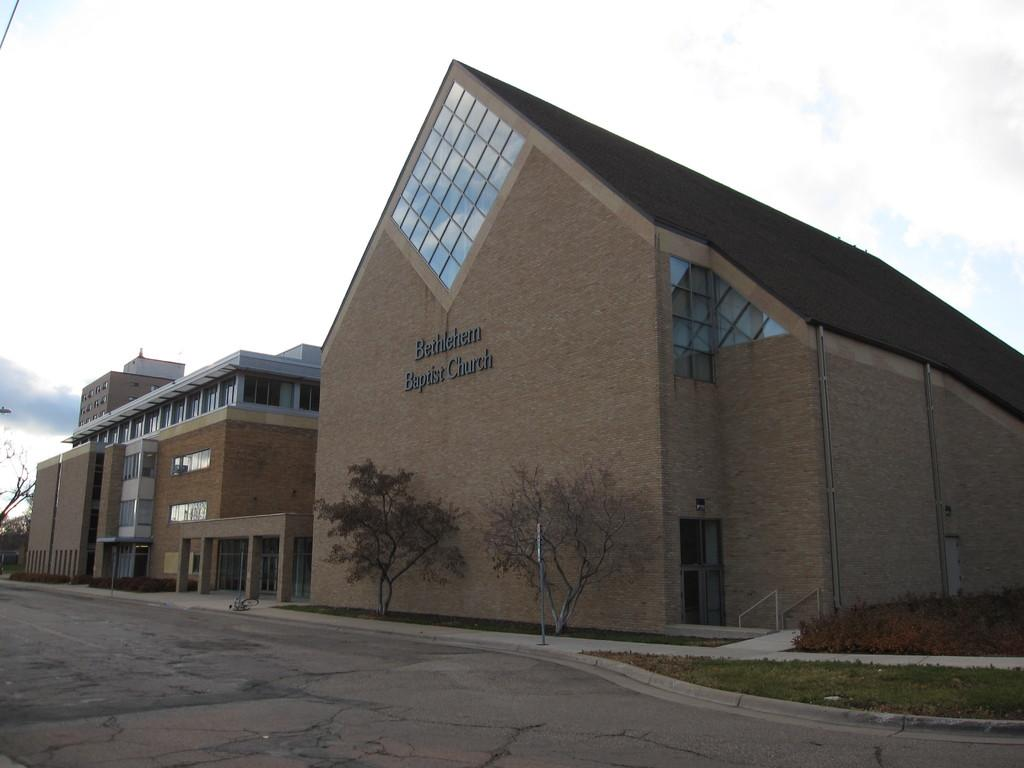What type of structures can be seen on the right side of the image? There are buildings on the right side of the image. What is the color and texture of the ground in the image? There is green grass visible in the image. What type of vegetation is present in the image? There are trees in the image. What can be seen in the sky in the image? Clouds are present in the sky in the image. What type of bun is being used to hold the clouds together in the image? There is no bun present in the image; the clouds are not being held together by any bun. 